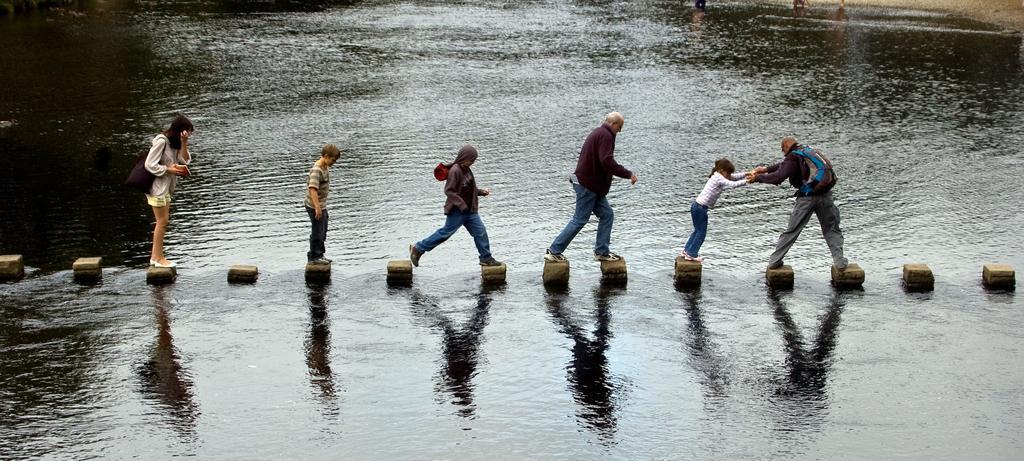Describe this image in one or two sentences. At the center of the image there are few persons crossing the water with the help of the bricks arranged in the middle of the water. 